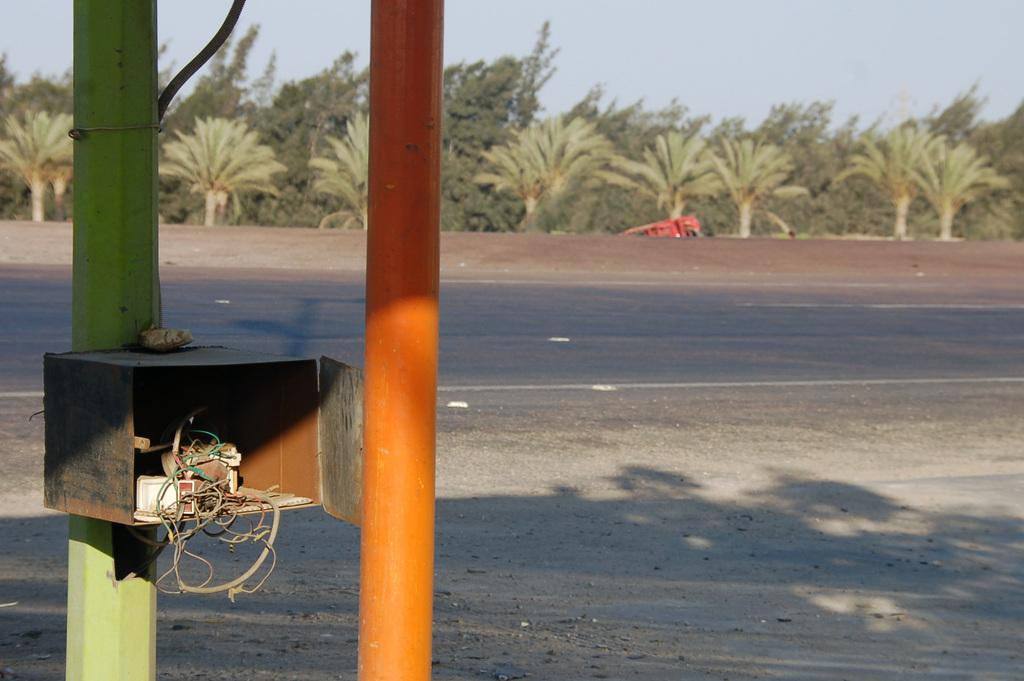What objects can be seen in the image that are used for support or stability? There are two poles in the image that can be used for support or stability. What is attached to one of the poles? One of the poles has a fuse box attached to it. What type of natural vegetation is present in the image? There are trees in the image. What is visible in the background of the image? The sky is visible in the background of the image. What type of machine is being operated by hand in the image? There is no machine being operated by hand in the image. What is the edge of the image used for? The edge of the image is not a physical object or feature in the scene; it is simply the boundary of the photograph. 